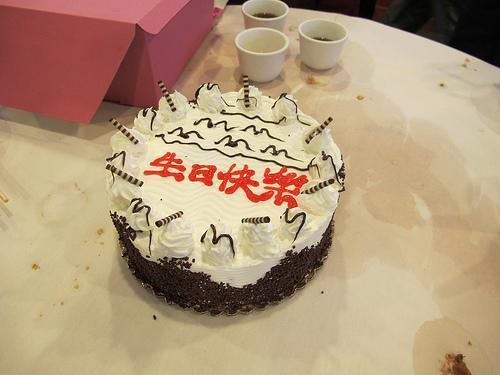How many boxes are there?
Give a very brief answer. 1. 